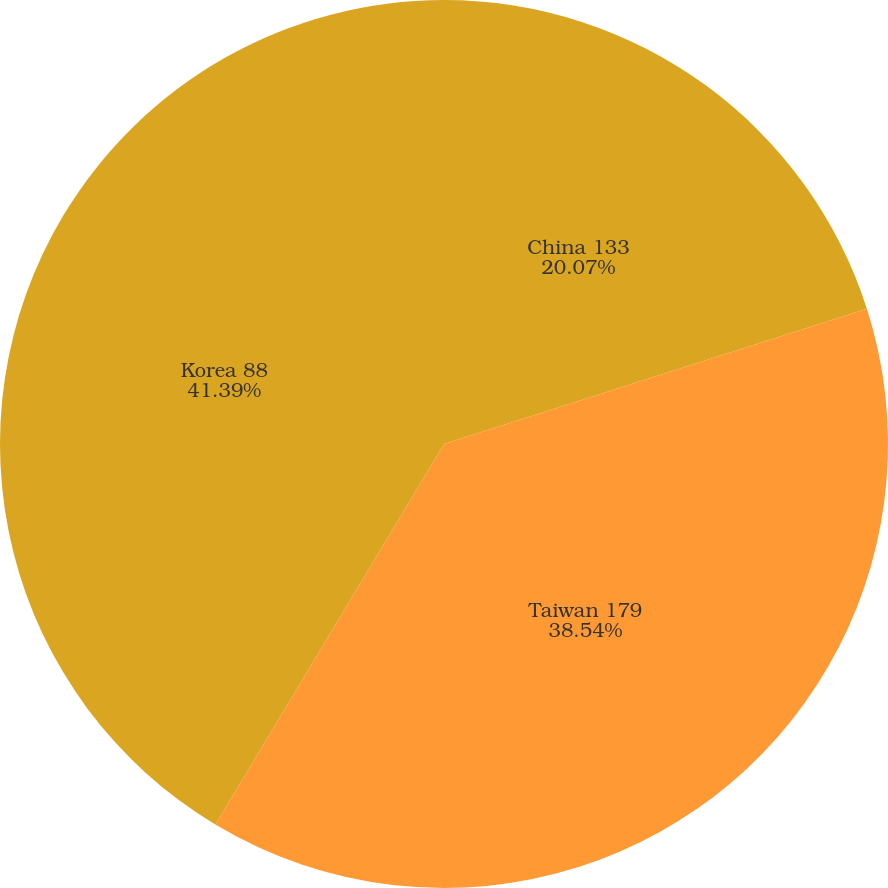Convert chart. <chart><loc_0><loc_0><loc_500><loc_500><pie_chart><fcel>China 133<fcel>Taiwan 179<fcel>Korea 88<nl><fcel>20.07%<fcel>38.54%<fcel>41.39%<nl></chart> 